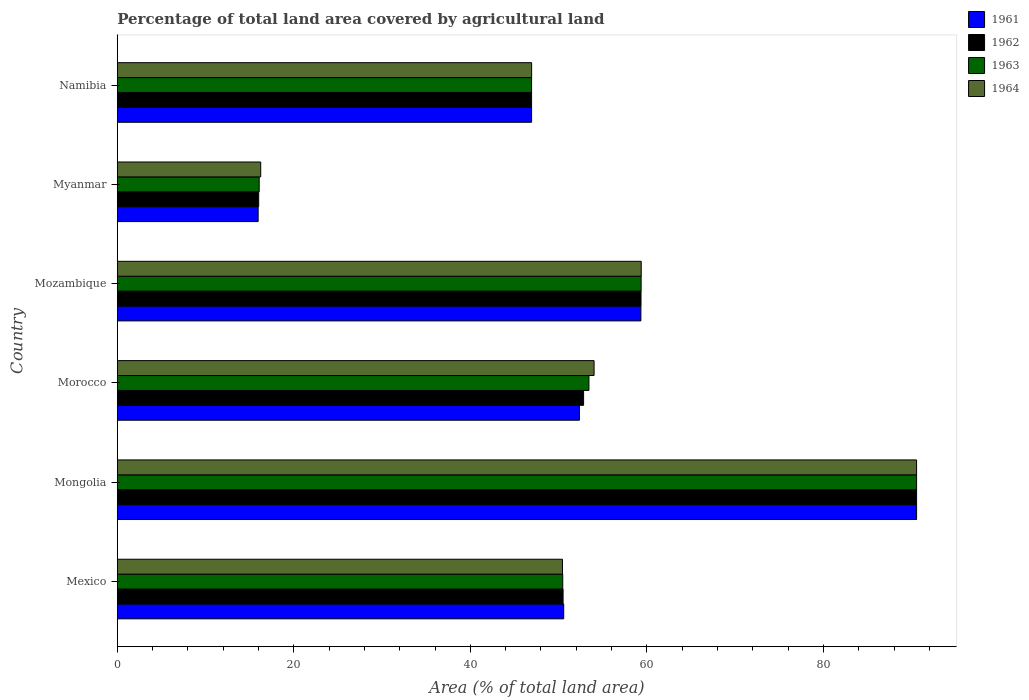How many different coloured bars are there?
Offer a terse response. 4. Are the number of bars per tick equal to the number of legend labels?
Offer a terse response. Yes. What is the label of the 3rd group of bars from the top?
Your answer should be compact. Mozambique. In how many cases, is the number of bars for a given country not equal to the number of legend labels?
Provide a succinct answer. 0. What is the percentage of agricultural land in 1961 in Mexico?
Provide a short and direct response. 50.58. Across all countries, what is the maximum percentage of agricultural land in 1964?
Keep it short and to the point. 90.55. Across all countries, what is the minimum percentage of agricultural land in 1963?
Provide a short and direct response. 16.08. In which country was the percentage of agricultural land in 1962 maximum?
Provide a succinct answer. Mongolia. In which country was the percentage of agricultural land in 1964 minimum?
Keep it short and to the point. Myanmar. What is the total percentage of agricultural land in 1963 in the graph?
Ensure brevity in your answer.  316.82. What is the difference between the percentage of agricultural land in 1963 in Morocco and that in Mozambique?
Offer a terse response. -5.91. What is the difference between the percentage of agricultural land in 1962 in Morocco and the percentage of agricultural land in 1964 in Mozambique?
Keep it short and to the point. -6.53. What is the average percentage of agricultural land in 1963 per country?
Ensure brevity in your answer.  52.8. What is the difference between the percentage of agricultural land in 1964 and percentage of agricultural land in 1963 in Namibia?
Offer a very short reply. 0. In how many countries, is the percentage of agricultural land in 1962 greater than 88 %?
Ensure brevity in your answer.  1. What is the ratio of the percentage of agricultural land in 1962 in Mexico to that in Namibia?
Your answer should be compact. 1.08. What is the difference between the highest and the second highest percentage of agricultural land in 1961?
Ensure brevity in your answer.  31.23. What is the difference between the highest and the lowest percentage of agricultural land in 1963?
Make the answer very short. 74.48. What does the 3rd bar from the top in Mexico represents?
Offer a terse response. 1962. How many bars are there?
Your answer should be very brief. 24. Are all the bars in the graph horizontal?
Give a very brief answer. Yes. How many countries are there in the graph?
Your answer should be compact. 6. Does the graph contain any zero values?
Give a very brief answer. No. How many legend labels are there?
Keep it short and to the point. 4. What is the title of the graph?
Offer a terse response. Percentage of total land area covered by agricultural land. What is the label or title of the X-axis?
Your answer should be very brief. Area (% of total land area). What is the Area (% of total land area) in 1961 in Mexico?
Provide a short and direct response. 50.58. What is the Area (% of total land area) in 1962 in Mexico?
Your answer should be compact. 50.5. What is the Area (% of total land area) in 1963 in Mexico?
Ensure brevity in your answer.  50.47. What is the Area (% of total land area) of 1964 in Mexico?
Keep it short and to the point. 50.44. What is the Area (% of total land area) in 1961 in Mongolia?
Provide a short and direct response. 90.56. What is the Area (% of total land area) of 1962 in Mongolia?
Keep it short and to the point. 90.56. What is the Area (% of total land area) in 1963 in Mongolia?
Offer a very short reply. 90.56. What is the Area (% of total land area) in 1964 in Mongolia?
Provide a succinct answer. 90.55. What is the Area (% of total land area) of 1961 in Morocco?
Your answer should be compact. 52.36. What is the Area (% of total land area) of 1962 in Morocco?
Give a very brief answer. 52.83. What is the Area (% of total land area) in 1963 in Morocco?
Provide a succinct answer. 53.43. What is the Area (% of total land area) of 1964 in Morocco?
Provide a succinct answer. 54.02. What is the Area (% of total land area) of 1961 in Mozambique?
Provide a succinct answer. 59.32. What is the Area (% of total land area) in 1962 in Mozambique?
Make the answer very short. 59.34. What is the Area (% of total land area) of 1963 in Mozambique?
Offer a terse response. 59.35. What is the Area (% of total land area) of 1964 in Mozambique?
Provide a succinct answer. 59.36. What is the Area (% of total land area) in 1961 in Myanmar?
Offer a very short reply. 15.96. What is the Area (% of total land area) of 1962 in Myanmar?
Provide a short and direct response. 16.02. What is the Area (% of total land area) in 1963 in Myanmar?
Your answer should be very brief. 16.08. What is the Area (% of total land area) of 1964 in Myanmar?
Your response must be concise. 16.25. What is the Area (% of total land area) in 1961 in Namibia?
Your answer should be very brief. 46.94. What is the Area (% of total land area) in 1962 in Namibia?
Keep it short and to the point. 46.94. What is the Area (% of total land area) in 1963 in Namibia?
Give a very brief answer. 46.94. What is the Area (% of total land area) of 1964 in Namibia?
Offer a terse response. 46.94. Across all countries, what is the maximum Area (% of total land area) of 1961?
Your answer should be very brief. 90.56. Across all countries, what is the maximum Area (% of total land area) in 1962?
Give a very brief answer. 90.56. Across all countries, what is the maximum Area (% of total land area) in 1963?
Offer a very short reply. 90.56. Across all countries, what is the maximum Area (% of total land area) in 1964?
Provide a succinct answer. 90.55. Across all countries, what is the minimum Area (% of total land area) in 1961?
Give a very brief answer. 15.96. Across all countries, what is the minimum Area (% of total land area) of 1962?
Your answer should be very brief. 16.02. Across all countries, what is the minimum Area (% of total land area) of 1963?
Your answer should be very brief. 16.08. Across all countries, what is the minimum Area (% of total land area) of 1964?
Offer a very short reply. 16.25. What is the total Area (% of total land area) of 1961 in the graph?
Make the answer very short. 315.71. What is the total Area (% of total land area) in 1962 in the graph?
Your answer should be very brief. 316.18. What is the total Area (% of total land area) in 1963 in the graph?
Keep it short and to the point. 316.82. What is the total Area (% of total land area) in 1964 in the graph?
Provide a short and direct response. 317.56. What is the difference between the Area (% of total land area) in 1961 in Mexico and that in Mongolia?
Provide a short and direct response. -39.98. What is the difference between the Area (% of total land area) of 1962 in Mexico and that in Mongolia?
Keep it short and to the point. -40.05. What is the difference between the Area (% of total land area) in 1963 in Mexico and that in Mongolia?
Ensure brevity in your answer.  -40.09. What is the difference between the Area (% of total land area) in 1964 in Mexico and that in Mongolia?
Make the answer very short. -40.12. What is the difference between the Area (% of total land area) of 1961 in Mexico and that in Morocco?
Your answer should be very brief. -1.78. What is the difference between the Area (% of total land area) of 1962 in Mexico and that in Morocco?
Offer a very short reply. -2.32. What is the difference between the Area (% of total land area) in 1963 in Mexico and that in Morocco?
Offer a terse response. -2.97. What is the difference between the Area (% of total land area) in 1964 in Mexico and that in Morocco?
Keep it short and to the point. -3.58. What is the difference between the Area (% of total land area) in 1961 in Mexico and that in Mozambique?
Offer a very short reply. -8.75. What is the difference between the Area (% of total land area) in 1962 in Mexico and that in Mozambique?
Your answer should be very brief. -8.83. What is the difference between the Area (% of total land area) in 1963 in Mexico and that in Mozambique?
Ensure brevity in your answer.  -8.88. What is the difference between the Area (% of total land area) in 1964 in Mexico and that in Mozambique?
Give a very brief answer. -8.92. What is the difference between the Area (% of total land area) of 1961 in Mexico and that in Myanmar?
Provide a short and direct response. 34.62. What is the difference between the Area (% of total land area) of 1962 in Mexico and that in Myanmar?
Your answer should be very brief. 34.48. What is the difference between the Area (% of total land area) of 1963 in Mexico and that in Myanmar?
Your answer should be compact. 34.39. What is the difference between the Area (% of total land area) in 1964 in Mexico and that in Myanmar?
Provide a short and direct response. 34.19. What is the difference between the Area (% of total land area) of 1961 in Mexico and that in Namibia?
Keep it short and to the point. 3.64. What is the difference between the Area (% of total land area) of 1962 in Mexico and that in Namibia?
Provide a succinct answer. 3.57. What is the difference between the Area (% of total land area) of 1963 in Mexico and that in Namibia?
Your answer should be compact. 3.53. What is the difference between the Area (% of total land area) in 1964 in Mexico and that in Namibia?
Offer a very short reply. 3.5. What is the difference between the Area (% of total land area) of 1961 in Mongolia and that in Morocco?
Keep it short and to the point. 38.2. What is the difference between the Area (% of total land area) in 1962 in Mongolia and that in Morocco?
Ensure brevity in your answer.  37.73. What is the difference between the Area (% of total land area) in 1963 in Mongolia and that in Morocco?
Make the answer very short. 37.12. What is the difference between the Area (% of total land area) in 1964 in Mongolia and that in Morocco?
Provide a short and direct response. 36.54. What is the difference between the Area (% of total land area) in 1961 in Mongolia and that in Mozambique?
Offer a very short reply. 31.23. What is the difference between the Area (% of total land area) of 1962 in Mongolia and that in Mozambique?
Offer a terse response. 31.22. What is the difference between the Area (% of total land area) in 1963 in Mongolia and that in Mozambique?
Keep it short and to the point. 31.21. What is the difference between the Area (% of total land area) of 1964 in Mongolia and that in Mozambique?
Provide a succinct answer. 31.2. What is the difference between the Area (% of total land area) in 1961 in Mongolia and that in Myanmar?
Provide a succinct answer. 74.6. What is the difference between the Area (% of total land area) in 1962 in Mongolia and that in Myanmar?
Offer a terse response. 74.53. What is the difference between the Area (% of total land area) in 1963 in Mongolia and that in Myanmar?
Ensure brevity in your answer.  74.48. What is the difference between the Area (% of total land area) in 1964 in Mongolia and that in Myanmar?
Provide a succinct answer. 74.3. What is the difference between the Area (% of total land area) of 1961 in Mongolia and that in Namibia?
Provide a short and direct response. 43.62. What is the difference between the Area (% of total land area) in 1962 in Mongolia and that in Namibia?
Offer a very short reply. 43.62. What is the difference between the Area (% of total land area) in 1963 in Mongolia and that in Namibia?
Your answer should be very brief. 43.62. What is the difference between the Area (% of total land area) in 1964 in Mongolia and that in Namibia?
Make the answer very short. 43.61. What is the difference between the Area (% of total land area) of 1961 in Morocco and that in Mozambique?
Keep it short and to the point. -6.96. What is the difference between the Area (% of total land area) of 1962 in Morocco and that in Mozambique?
Your response must be concise. -6.51. What is the difference between the Area (% of total land area) of 1963 in Morocco and that in Mozambique?
Give a very brief answer. -5.91. What is the difference between the Area (% of total land area) in 1964 in Morocco and that in Mozambique?
Your response must be concise. -5.34. What is the difference between the Area (% of total land area) of 1961 in Morocco and that in Myanmar?
Offer a terse response. 36.4. What is the difference between the Area (% of total land area) of 1962 in Morocco and that in Myanmar?
Give a very brief answer. 36.81. What is the difference between the Area (% of total land area) of 1963 in Morocco and that in Myanmar?
Provide a succinct answer. 37.36. What is the difference between the Area (% of total land area) in 1964 in Morocco and that in Myanmar?
Your answer should be compact. 37.77. What is the difference between the Area (% of total land area) in 1961 in Morocco and that in Namibia?
Your response must be concise. 5.42. What is the difference between the Area (% of total land area) of 1962 in Morocco and that in Namibia?
Offer a terse response. 5.89. What is the difference between the Area (% of total land area) in 1963 in Morocco and that in Namibia?
Make the answer very short. 6.5. What is the difference between the Area (% of total land area) of 1964 in Morocco and that in Namibia?
Make the answer very short. 7.08. What is the difference between the Area (% of total land area) of 1961 in Mozambique and that in Myanmar?
Your response must be concise. 43.36. What is the difference between the Area (% of total land area) of 1962 in Mozambique and that in Myanmar?
Offer a very short reply. 43.31. What is the difference between the Area (% of total land area) in 1963 in Mozambique and that in Myanmar?
Offer a very short reply. 43.27. What is the difference between the Area (% of total land area) of 1964 in Mozambique and that in Myanmar?
Your response must be concise. 43.11. What is the difference between the Area (% of total land area) in 1961 in Mozambique and that in Namibia?
Your answer should be very brief. 12.39. What is the difference between the Area (% of total land area) in 1962 in Mozambique and that in Namibia?
Provide a succinct answer. 12.4. What is the difference between the Area (% of total land area) of 1963 in Mozambique and that in Namibia?
Offer a very short reply. 12.41. What is the difference between the Area (% of total land area) in 1964 in Mozambique and that in Namibia?
Offer a terse response. 12.42. What is the difference between the Area (% of total land area) of 1961 in Myanmar and that in Namibia?
Provide a succinct answer. -30.98. What is the difference between the Area (% of total land area) of 1962 in Myanmar and that in Namibia?
Ensure brevity in your answer.  -30.92. What is the difference between the Area (% of total land area) of 1963 in Myanmar and that in Namibia?
Offer a very short reply. -30.86. What is the difference between the Area (% of total land area) of 1964 in Myanmar and that in Namibia?
Offer a terse response. -30.69. What is the difference between the Area (% of total land area) of 1961 in Mexico and the Area (% of total land area) of 1962 in Mongolia?
Ensure brevity in your answer.  -39.98. What is the difference between the Area (% of total land area) of 1961 in Mexico and the Area (% of total land area) of 1963 in Mongolia?
Provide a short and direct response. -39.98. What is the difference between the Area (% of total land area) of 1961 in Mexico and the Area (% of total land area) of 1964 in Mongolia?
Your response must be concise. -39.98. What is the difference between the Area (% of total land area) of 1962 in Mexico and the Area (% of total land area) of 1963 in Mongolia?
Make the answer very short. -40.05. What is the difference between the Area (% of total land area) in 1962 in Mexico and the Area (% of total land area) in 1964 in Mongolia?
Ensure brevity in your answer.  -40.05. What is the difference between the Area (% of total land area) of 1963 in Mexico and the Area (% of total land area) of 1964 in Mongolia?
Keep it short and to the point. -40.09. What is the difference between the Area (% of total land area) in 1961 in Mexico and the Area (% of total land area) in 1962 in Morocco?
Provide a succinct answer. -2.25. What is the difference between the Area (% of total land area) of 1961 in Mexico and the Area (% of total land area) of 1963 in Morocco?
Make the answer very short. -2.86. What is the difference between the Area (% of total land area) in 1961 in Mexico and the Area (% of total land area) in 1964 in Morocco?
Your answer should be very brief. -3.44. What is the difference between the Area (% of total land area) in 1962 in Mexico and the Area (% of total land area) in 1963 in Morocco?
Your answer should be very brief. -2.93. What is the difference between the Area (% of total land area) of 1962 in Mexico and the Area (% of total land area) of 1964 in Morocco?
Your response must be concise. -3.51. What is the difference between the Area (% of total land area) of 1963 in Mexico and the Area (% of total land area) of 1964 in Morocco?
Ensure brevity in your answer.  -3.55. What is the difference between the Area (% of total land area) of 1961 in Mexico and the Area (% of total land area) of 1962 in Mozambique?
Your response must be concise. -8.76. What is the difference between the Area (% of total land area) in 1961 in Mexico and the Area (% of total land area) in 1963 in Mozambique?
Offer a terse response. -8.77. What is the difference between the Area (% of total land area) in 1961 in Mexico and the Area (% of total land area) in 1964 in Mozambique?
Your response must be concise. -8.78. What is the difference between the Area (% of total land area) in 1962 in Mexico and the Area (% of total land area) in 1963 in Mozambique?
Your answer should be very brief. -8.84. What is the difference between the Area (% of total land area) of 1962 in Mexico and the Area (% of total land area) of 1964 in Mozambique?
Your answer should be very brief. -8.85. What is the difference between the Area (% of total land area) of 1963 in Mexico and the Area (% of total land area) of 1964 in Mozambique?
Keep it short and to the point. -8.89. What is the difference between the Area (% of total land area) in 1961 in Mexico and the Area (% of total land area) in 1962 in Myanmar?
Offer a terse response. 34.55. What is the difference between the Area (% of total land area) of 1961 in Mexico and the Area (% of total land area) of 1963 in Myanmar?
Your answer should be compact. 34.5. What is the difference between the Area (% of total land area) in 1961 in Mexico and the Area (% of total land area) in 1964 in Myanmar?
Make the answer very short. 34.33. What is the difference between the Area (% of total land area) in 1962 in Mexico and the Area (% of total land area) in 1963 in Myanmar?
Give a very brief answer. 34.43. What is the difference between the Area (% of total land area) in 1962 in Mexico and the Area (% of total land area) in 1964 in Myanmar?
Your response must be concise. 34.25. What is the difference between the Area (% of total land area) of 1963 in Mexico and the Area (% of total land area) of 1964 in Myanmar?
Your response must be concise. 34.22. What is the difference between the Area (% of total land area) in 1961 in Mexico and the Area (% of total land area) in 1962 in Namibia?
Make the answer very short. 3.64. What is the difference between the Area (% of total land area) in 1961 in Mexico and the Area (% of total land area) in 1963 in Namibia?
Your answer should be compact. 3.64. What is the difference between the Area (% of total land area) of 1961 in Mexico and the Area (% of total land area) of 1964 in Namibia?
Your answer should be very brief. 3.63. What is the difference between the Area (% of total land area) of 1962 in Mexico and the Area (% of total land area) of 1963 in Namibia?
Ensure brevity in your answer.  3.57. What is the difference between the Area (% of total land area) of 1962 in Mexico and the Area (% of total land area) of 1964 in Namibia?
Ensure brevity in your answer.  3.56. What is the difference between the Area (% of total land area) in 1963 in Mexico and the Area (% of total land area) in 1964 in Namibia?
Provide a short and direct response. 3.53. What is the difference between the Area (% of total land area) of 1961 in Mongolia and the Area (% of total land area) of 1962 in Morocco?
Your response must be concise. 37.73. What is the difference between the Area (% of total land area) of 1961 in Mongolia and the Area (% of total land area) of 1963 in Morocco?
Make the answer very short. 37.12. What is the difference between the Area (% of total land area) in 1961 in Mongolia and the Area (% of total land area) in 1964 in Morocco?
Your answer should be compact. 36.54. What is the difference between the Area (% of total land area) of 1962 in Mongolia and the Area (% of total land area) of 1963 in Morocco?
Keep it short and to the point. 37.12. What is the difference between the Area (% of total land area) of 1962 in Mongolia and the Area (% of total land area) of 1964 in Morocco?
Provide a short and direct response. 36.54. What is the difference between the Area (% of total land area) of 1963 in Mongolia and the Area (% of total land area) of 1964 in Morocco?
Your answer should be very brief. 36.54. What is the difference between the Area (% of total land area) in 1961 in Mongolia and the Area (% of total land area) in 1962 in Mozambique?
Provide a short and direct response. 31.22. What is the difference between the Area (% of total land area) of 1961 in Mongolia and the Area (% of total land area) of 1963 in Mozambique?
Offer a very short reply. 31.21. What is the difference between the Area (% of total land area) of 1961 in Mongolia and the Area (% of total land area) of 1964 in Mozambique?
Your answer should be compact. 31.2. What is the difference between the Area (% of total land area) of 1962 in Mongolia and the Area (% of total land area) of 1963 in Mozambique?
Offer a very short reply. 31.21. What is the difference between the Area (% of total land area) of 1962 in Mongolia and the Area (% of total land area) of 1964 in Mozambique?
Offer a terse response. 31.2. What is the difference between the Area (% of total land area) of 1963 in Mongolia and the Area (% of total land area) of 1964 in Mozambique?
Make the answer very short. 31.2. What is the difference between the Area (% of total land area) in 1961 in Mongolia and the Area (% of total land area) in 1962 in Myanmar?
Keep it short and to the point. 74.53. What is the difference between the Area (% of total land area) in 1961 in Mongolia and the Area (% of total land area) in 1963 in Myanmar?
Your answer should be compact. 74.48. What is the difference between the Area (% of total land area) in 1961 in Mongolia and the Area (% of total land area) in 1964 in Myanmar?
Provide a succinct answer. 74.31. What is the difference between the Area (% of total land area) of 1962 in Mongolia and the Area (% of total land area) of 1963 in Myanmar?
Keep it short and to the point. 74.48. What is the difference between the Area (% of total land area) of 1962 in Mongolia and the Area (% of total land area) of 1964 in Myanmar?
Provide a short and direct response. 74.31. What is the difference between the Area (% of total land area) in 1963 in Mongolia and the Area (% of total land area) in 1964 in Myanmar?
Your answer should be very brief. 74.31. What is the difference between the Area (% of total land area) in 1961 in Mongolia and the Area (% of total land area) in 1962 in Namibia?
Your answer should be compact. 43.62. What is the difference between the Area (% of total land area) in 1961 in Mongolia and the Area (% of total land area) in 1963 in Namibia?
Offer a very short reply. 43.62. What is the difference between the Area (% of total land area) in 1961 in Mongolia and the Area (% of total land area) in 1964 in Namibia?
Ensure brevity in your answer.  43.61. What is the difference between the Area (% of total land area) in 1962 in Mongolia and the Area (% of total land area) in 1963 in Namibia?
Keep it short and to the point. 43.62. What is the difference between the Area (% of total land area) of 1962 in Mongolia and the Area (% of total land area) of 1964 in Namibia?
Keep it short and to the point. 43.61. What is the difference between the Area (% of total land area) of 1963 in Mongolia and the Area (% of total land area) of 1964 in Namibia?
Your answer should be very brief. 43.61. What is the difference between the Area (% of total land area) of 1961 in Morocco and the Area (% of total land area) of 1962 in Mozambique?
Your answer should be very brief. -6.98. What is the difference between the Area (% of total land area) in 1961 in Morocco and the Area (% of total land area) in 1963 in Mozambique?
Make the answer very short. -6.99. What is the difference between the Area (% of total land area) of 1961 in Morocco and the Area (% of total land area) of 1964 in Mozambique?
Your answer should be compact. -7. What is the difference between the Area (% of total land area) of 1962 in Morocco and the Area (% of total land area) of 1963 in Mozambique?
Give a very brief answer. -6.52. What is the difference between the Area (% of total land area) of 1962 in Morocco and the Area (% of total land area) of 1964 in Mozambique?
Your answer should be very brief. -6.53. What is the difference between the Area (% of total land area) in 1963 in Morocco and the Area (% of total land area) in 1964 in Mozambique?
Offer a terse response. -5.92. What is the difference between the Area (% of total land area) of 1961 in Morocco and the Area (% of total land area) of 1962 in Myanmar?
Make the answer very short. 36.34. What is the difference between the Area (% of total land area) in 1961 in Morocco and the Area (% of total land area) in 1963 in Myanmar?
Keep it short and to the point. 36.28. What is the difference between the Area (% of total land area) of 1961 in Morocco and the Area (% of total land area) of 1964 in Myanmar?
Keep it short and to the point. 36.11. What is the difference between the Area (% of total land area) in 1962 in Morocco and the Area (% of total land area) in 1963 in Myanmar?
Your answer should be very brief. 36.75. What is the difference between the Area (% of total land area) of 1962 in Morocco and the Area (% of total land area) of 1964 in Myanmar?
Offer a very short reply. 36.58. What is the difference between the Area (% of total land area) in 1963 in Morocco and the Area (% of total land area) in 1964 in Myanmar?
Keep it short and to the point. 37.18. What is the difference between the Area (% of total land area) of 1961 in Morocco and the Area (% of total land area) of 1962 in Namibia?
Give a very brief answer. 5.42. What is the difference between the Area (% of total land area) in 1961 in Morocco and the Area (% of total land area) in 1963 in Namibia?
Your response must be concise. 5.42. What is the difference between the Area (% of total land area) in 1961 in Morocco and the Area (% of total land area) in 1964 in Namibia?
Offer a terse response. 5.42. What is the difference between the Area (% of total land area) of 1962 in Morocco and the Area (% of total land area) of 1963 in Namibia?
Your answer should be compact. 5.89. What is the difference between the Area (% of total land area) of 1962 in Morocco and the Area (% of total land area) of 1964 in Namibia?
Offer a terse response. 5.89. What is the difference between the Area (% of total land area) in 1963 in Morocco and the Area (% of total land area) in 1964 in Namibia?
Your answer should be very brief. 6.49. What is the difference between the Area (% of total land area) of 1961 in Mozambique and the Area (% of total land area) of 1962 in Myanmar?
Offer a terse response. 43.3. What is the difference between the Area (% of total land area) in 1961 in Mozambique and the Area (% of total land area) in 1963 in Myanmar?
Your response must be concise. 43.24. What is the difference between the Area (% of total land area) of 1961 in Mozambique and the Area (% of total land area) of 1964 in Myanmar?
Provide a short and direct response. 43.07. What is the difference between the Area (% of total land area) of 1962 in Mozambique and the Area (% of total land area) of 1963 in Myanmar?
Your response must be concise. 43.26. What is the difference between the Area (% of total land area) in 1962 in Mozambique and the Area (% of total land area) in 1964 in Myanmar?
Make the answer very short. 43.09. What is the difference between the Area (% of total land area) in 1963 in Mozambique and the Area (% of total land area) in 1964 in Myanmar?
Give a very brief answer. 43.1. What is the difference between the Area (% of total land area) of 1961 in Mozambique and the Area (% of total land area) of 1962 in Namibia?
Give a very brief answer. 12.39. What is the difference between the Area (% of total land area) in 1961 in Mozambique and the Area (% of total land area) in 1963 in Namibia?
Make the answer very short. 12.39. What is the difference between the Area (% of total land area) in 1961 in Mozambique and the Area (% of total land area) in 1964 in Namibia?
Your answer should be very brief. 12.38. What is the difference between the Area (% of total land area) in 1962 in Mozambique and the Area (% of total land area) in 1963 in Namibia?
Your response must be concise. 12.4. What is the difference between the Area (% of total land area) of 1962 in Mozambique and the Area (% of total land area) of 1964 in Namibia?
Offer a very short reply. 12.39. What is the difference between the Area (% of total land area) in 1963 in Mozambique and the Area (% of total land area) in 1964 in Namibia?
Your response must be concise. 12.41. What is the difference between the Area (% of total land area) in 1961 in Myanmar and the Area (% of total land area) in 1962 in Namibia?
Your answer should be compact. -30.98. What is the difference between the Area (% of total land area) in 1961 in Myanmar and the Area (% of total land area) in 1963 in Namibia?
Ensure brevity in your answer.  -30.98. What is the difference between the Area (% of total land area) in 1961 in Myanmar and the Area (% of total land area) in 1964 in Namibia?
Your answer should be very brief. -30.98. What is the difference between the Area (% of total land area) of 1962 in Myanmar and the Area (% of total land area) of 1963 in Namibia?
Your response must be concise. -30.92. What is the difference between the Area (% of total land area) in 1962 in Myanmar and the Area (% of total land area) in 1964 in Namibia?
Your answer should be very brief. -30.92. What is the difference between the Area (% of total land area) of 1963 in Myanmar and the Area (% of total land area) of 1964 in Namibia?
Make the answer very short. -30.86. What is the average Area (% of total land area) in 1961 per country?
Your answer should be compact. 52.62. What is the average Area (% of total land area) in 1962 per country?
Offer a very short reply. 52.7. What is the average Area (% of total land area) of 1963 per country?
Ensure brevity in your answer.  52.8. What is the average Area (% of total land area) in 1964 per country?
Offer a very short reply. 52.93. What is the difference between the Area (% of total land area) of 1961 and Area (% of total land area) of 1962 in Mexico?
Give a very brief answer. 0.07. What is the difference between the Area (% of total land area) in 1961 and Area (% of total land area) in 1963 in Mexico?
Provide a short and direct response. 0.11. What is the difference between the Area (% of total land area) of 1961 and Area (% of total land area) of 1964 in Mexico?
Your response must be concise. 0.14. What is the difference between the Area (% of total land area) in 1962 and Area (% of total land area) in 1963 in Mexico?
Provide a succinct answer. 0.04. What is the difference between the Area (% of total land area) in 1962 and Area (% of total land area) in 1964 in Mexico?
Provide a succinct answer. 0.07. What is the difference between the Area (% of total land area) of 1963 and Area (% of total land area) of 1964 in Mexico?
Offer a very short reply. 0.03. What is the difference between the Area (% of total land area) of 1961 and Area (% of total land area) of 1962 in Mongolia?
Your answer should be very brief. 0. What is the difference between the Area (% of total land area) of 1961 and Area (% of total land area) of 1963 in Mongolia?
Offer a very short reply. 0. What is the difference between the Area (% of total land area) in 1961 and Area (% of total land area) in 1964 in Mongolia?
Make the answer very short. 0. What is the difference between the Area (% of total land area) in 1962 and Area (% of total land area) in 1964 in Mongolia?
Your response must be concise. 0. What is the difference between the Area (% of total land area) of 1963 and Area (% of total land area) of 1964 in Mongolia?
Your answer should be very brief. 0. What is the difference between the Area (% of total land area) in 1961 and Area (% of total land area) in 1962 in Morocco?
Keep it short and to the point. -0.47. What is the difference between the Area (% of total land area) in 1961 and Area (% of total land area) in 1963 in Morocco?
Your answer should be very brief. -1.08. What is the difference between the Area (% of total land area) in 1961 and Area (% of total land area) in 1964 in Morocco?
Your answer should be compact. -1.66. What is the difference between the Area (% of total land area) in 1962 and Area (% of total land area) in 1963 in Morocco?
Provide a succinct answer. -0.6. What is the difference between the Area (% of total land area) in 1962 and Area (% of total land area) in 1964 in Morocco?
Your answer should be compact. -1.19. What is the difference between the Area (% of total land area) in 1963 and Area (% of total land area) in 1964 in Morocco?
Offer a terse response. -0.58. What is the difference between the Area (% of total land area) of 1961 and Area (% of total land area) of 1962 in Mozambique?
Offer a very short reply. -0.01. What is the difference between the Area (% of total land area) in 1961 and Area (% of total land area) in 1963 in Mozambique?
Make the answer very short. -0.03. What is the difference between the Area (% of total land area) of 1961 and Area (% of total land area) of 1964 in Mozambique?
Your response must be concise. -0.04. What is the difference between the Area (% of total land area) in 1962 and Area (% of total land area) in 1963 in Mozambique?
Your answer should be compact. -0.01. What is the difference between the Area (% of total land area) in 1962 and Area (% of total land area) in 1964 in Mozambique?
Ensure brevity in your answer.  -0.02. What is the difference between the Area (% of total land area) in 1963 and Area (% of total land area) in 1964 in Mozambique?
Offer a terse response. -0.01. What is the difference between the Area (% of total land area) of 1961 and Area (% of total land area) of 1962 in Myanmar?
Ensure brevity in your answer.  -0.06. What is the difference between the Area (% of total land area) in 1961 and Area (% of total land area) in 1963 in Myanmar?
Your answer should be compact. -0.12. What is the difference between the Area (% of total land area) in 1961 and Area (% of total land area) in 1964 in Myanmar?
Give a very brief answer. -0.29. What is the difference between the Area (% of total land area) in 1962 and Area (% of total land area) in 1963 in Myanmar?
Provide a succinct answer. -0.06. What is the difference between the Area (% of total land area) in 1962 and Area (% of total land area) in 1964 in Myanmar?
Provide a short and direct response. -0.23. What is the difference between the Area (% of total land area) of 1963 and Area (% of total land area) of 1964 in Myanmar?
Your answer should be very brief. -0.17. What is the difference between the Area (% of total land area) of 1961 and Area (% of total land area) of 1963 in Namibia?
Your response must be concise. 0. What is the difference between the Area (% of total land area) in 1961 and Area (% of total land area) in 1964 in Namibia?
Keep it short and to the point. -0. What is the difference between the Area (% of total land area) of 1962 and Area (% of total land area) of 1964 in Namibia?
Make the answer very short. -0. What is the difference between the Area (% of total land area) in 1963 and Area (% of total land area) in 1964 in Namibia?
Provide a short and direct response. -0. What is the ratio of the Area (% of total land area) of 1961 in Mexico to that in Mongolia?
Your answer should be compact. 0.56. What is the ratio of the Area (% of total land area) in 1962 in Mexico to that in Mongolia?
Provide a succinct answer. 0.56. What is the ratio of the Area (% of total land area) in 1963 in Mexico to that in Mongolia?
Give a very brief answer. 0.56. What is the ratio of the Area (% of total land area) in 1964 in Mexico to that in Mongolia?
Offer a terse response. 0.56. What is the ratio of the Area (% of total land area) in 1961 in Mexico to that in Morocco?
Your answer should be very brief. 0.97. What is the ratio of the Area (% of total land area) in 1962 in Mexico to that in Morocco?
Offer a very short reply. 0.96. What is the ratio of the Area (% of total land area) of 1963 in Mexico to that in Morocco?
Offer a very short reply. 0.94. What is the ratio of the Area (% of total land area) of 1964 in Mexico to that in Morocco?
Offer a terse response. 0.93. What is the ratio of the Area (% of total land area) of 1961 in Mexico to that in Mozambique?
Make the answer very short. 0.85. What is the ratio of the Area (% of total land area) of 1962 in Mexico to that in Mozambique?
Make the answer very short. 0.85. What is the ratio of the Area (% of total land area) in 1963 in Mexico to that in Mozambique?
Provide a succinct answer. 0.85. What is the ratio of the Area (% of total land area) of 1964 in Mexico to that in Mozambique?
Keep it short and to the point. 0.85. What is the ratio of the Area (% of total land area) of 1961 in Mexico to that in Myanmar?
Ensure brevity in your answer.  3.17. What is the ratio of the Area (% of total land area) of 1962 in Mexico to that in Myanmar?
Give a very brief answer. 3.15. What is the ratio of the Area (% of total land area) of 1963 in Mexico to that in Myanmar?
Provide a succinct answer. 3.14. What is the ratio of the Area (% of total land area) of 1964 in Mexico to that in Myanmar?
Provide a succinct answer. 3.1. What is the ratio of the Area (% of total land area) of 1961 in Mexico to that in Namibia?
Your answer should be compact. 1.08. What is the ratio of the Area (% of total land area) in 1962 in Mexico to that in Namibia?
Keep it short and to the point. 1.08. What is the ratio of the Area (% of total land area) of 1963 in Mexico to that in Namibia?
Provide a succinct answer. 1.08. What is the ratio of the Area (% of total land area) of 1964 in Mexico to that in Namibia?
Provide a succinct answer. 1.07. What is the ratio of the Area (% of total land area) in 1961 in Mongolia to that in Morocco?
Ensure brevity in your answer.  1.73. What is the ratio of the Area (% of total land area) of 1962 in Mongolia to that in Morocco?
Give a very brief answer. 1.71. What is the ratio of the Area (% of total land area) of 1963 in Mongolia to that in Morocco?
Offer a very short reply. 1.69. What is the ratio of the Area (% of total land area) in 1964 in Mongolia to that in Morocco?
Offer a terse response. 1.68. What is the ratio of the Area (% of total land area) in 1961 in Mongolia to that in Mozambique?
Your response must be concise. 1.53. What is the ratio of the Area (% of total land area) of 1962 in Mongolia to that in Mozambique?
Keep it short and to the point. 1.53. What is the ratio of the Area (% of total land area) of 1963 in Mongolia to that in Mozambique?
Keep it short and to the point. 1.53. What is the ratio of the Area (% of total land area) in 1964 in Mongolia to that in Mozambique?
Your answer should be very brief. 1.53. What is the ratio of the Area (% of total land area) in 1961 in Mongolia to that in Myanmar?
Offer a very short reply. 5.67. What is the ratio of the Area (% of total land area) in 1962 in Mongolia to that in Myanmar?
Your answer should be very brief. 5.65. What is the ratio of the Area (% of total land area) in 1963 in Mongolia to that in Myanmar?
Give a very brief answer. 5.63. What is the ratio of the Area (% of total land area) in 1964 in Mongolia to that in Myanmar?
Provide a short and direct response. 5.57. What is the ratio of the Area (% of total land area) in 1961 in Mongolia to that in Namibia?
Provide a succinct answer. 1.93. What is the ratio of the Area (% of total land area) of 1962 in Mongolia to that in Namibia?
Keep it short and to the point. 1.93. What is the ratio of the Area (% of total land area) of 1963 in Mongolia to that in Namibia?
Make the answer very short. 1.93. What is the ratio of the Area (% of total land area) in 1964 in Mongolia to that in Namibia?
Offer a very short reply. 1.93. What is the ratio of the Area (% of total land area) of 1961 in Morocco to that in Mozambique?
Ensure brevity in your answer.  0.88. What is the ratio of the Area (% of total land area) of 1962 in Morocco to that in Mozambique?
Ensure brevity in your answer.  0.89. What is the ratio of the Area (% of total land area) in 1963 in Morocco to that in Mozambique?
Keep it short and to the point. 0.9. What is the ratio of the Area (% of total land area) of 1964 in Morocco to that in Mozambique?
Your response must be concise. 0.91. What is the ratio of the Area (% of total land area) in 1961 in Morocco to that in Myanmar?
Offer a terse response. 3.28. What is the ratio of the Area (% of total land area) in 1962 in Morocco to that in Myanmar?
Offer a very short reply. 3.3. What is the ratio of the Area (% of total land area) of 1963 in Morocco to that in Myanmar?
Keep it short and to the point. 3.32. What is the ratio of the Area (% of total land area) in 1964 in Morocco to that in Myanmar?
Offer a very short reply. 3.32. What is the ratio of the Area (% of total land area) of 1961 in Morocco to that in Namibia?
Provide a succinct answer. 1.12. What is the ratio of the Area (% of total land area) of 1962 in Morocco to that in Namibia?
Your answer should be compact. 1.13. What is the ratio of the Area (% of total land area) in 1963 in Morocco to that in Namibia?
Give a very brief answer. 1.14. What is the ratio of the Area (% of total land area) in 1964 in Morocco to that in Namibia?
Give a very brief answer. 1.15. What is the ratio of the Area (% of total land area) in 1961 in Mozambique to that in Myanmar?
Your answer should be very brief. 3.72. What is the ratio of the Area (% of total land area) in 1962 in Mozambique to that in Myanmar?
Provide a short and direct response. 3.7. What is the ratio of the Area (% of total land area) of 1963 in Mozambique to that in Myanmar?
Your answer should be compact. 3.69. What is the ratio of the Area (% of total land area) of 1964 in Mozambique to that in Myanmar?
Ensure brevity in your answer.  3.65. What is the ratio of the Area (% of total land area) in 1961 in Mozambique to that in Namibia?
Provide a short and direct response. 1.26. What is the ratio of the Area (% of total land area) in 1962 in Mozambique to that in Namibia?
Make the answer very short. 1.26. What is the ratio of the Area (% of total land area) in 1963 in Mozambique to that in Namibia?
Provide a short and direct response. 1.26. What is the ratio of the Area (% of total land area) in 1964 in Mozambique to that in Namibia?
Offer a very short reply. 1.26. What is the ratio of the Area (% of total land area) of 1961 in Myanmar to that in Namibia?
Provide a succinct answer. 0.34. What is the ratio of the Area (% of total land area) in 1962 in Myanmar to that in Namibia?
Provide a succinct answer. 0.34. What is the ratio of the Area (% of total land area) of 1963 in Myanmar to that in Namibia?
Ensure brevity in your answer.  0.34. What is the ratio of the Area (% of total land area) of 1964 in Myanmar to that in Namibia?
Ensure brevity in your answer.  0.35. What is the difference between the highest and the second highest Area (% of total land area) of 1961?
Provide a succinct answer. 31.23. What is the difference between the highest and the second highest Area (% of total land area) in 1962?
Keep it short and to the point. 31.22. What is the difference between the highest and the second highest Area (% of total land area) in 1963?
Ensure brevity in your answer.  31.21. What is the difference between the highest and the second highest Area (% of total land area) in 1964?
Offer a very short reply. 31.2. What is the difference between the highest and the lowest Area (% of total land area) in 1961?
Provide a short and direct response. 74.6. What is the difference between the highest and the lowest Area (% of total land area) in 1962?
Your response must be concise. 74.53. What is the difference between the highest and the lowest Area (% of total land area) in 1963?
Offer a very short reply. 74.48. What is the difference between the highest and the lowest Area (% of total land area) in 1964?
Provide a short and direct response. 74.3. 